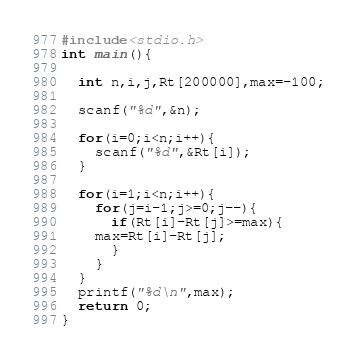Convert code to text. <code><loc_0><loc_0><loc_500><loc_500><_C_>#include<stdio.h>
int main(){

  int n,i,j,Rt[200000],max=-100;

  scanf("%d",&n);

  for(i=0;i<n;i++){
    scanf("%d",&Rt[i]);
  }

  for(i=1;i<n;i++){
    for(j=i-1;j>=0;j--){
      if(Rt[i]-Rt[j]>=max){
	max=Rt[i]-Rt[j];
      }
    }
  }
  printf("%d\n",max);
  return 0;
}</code> 